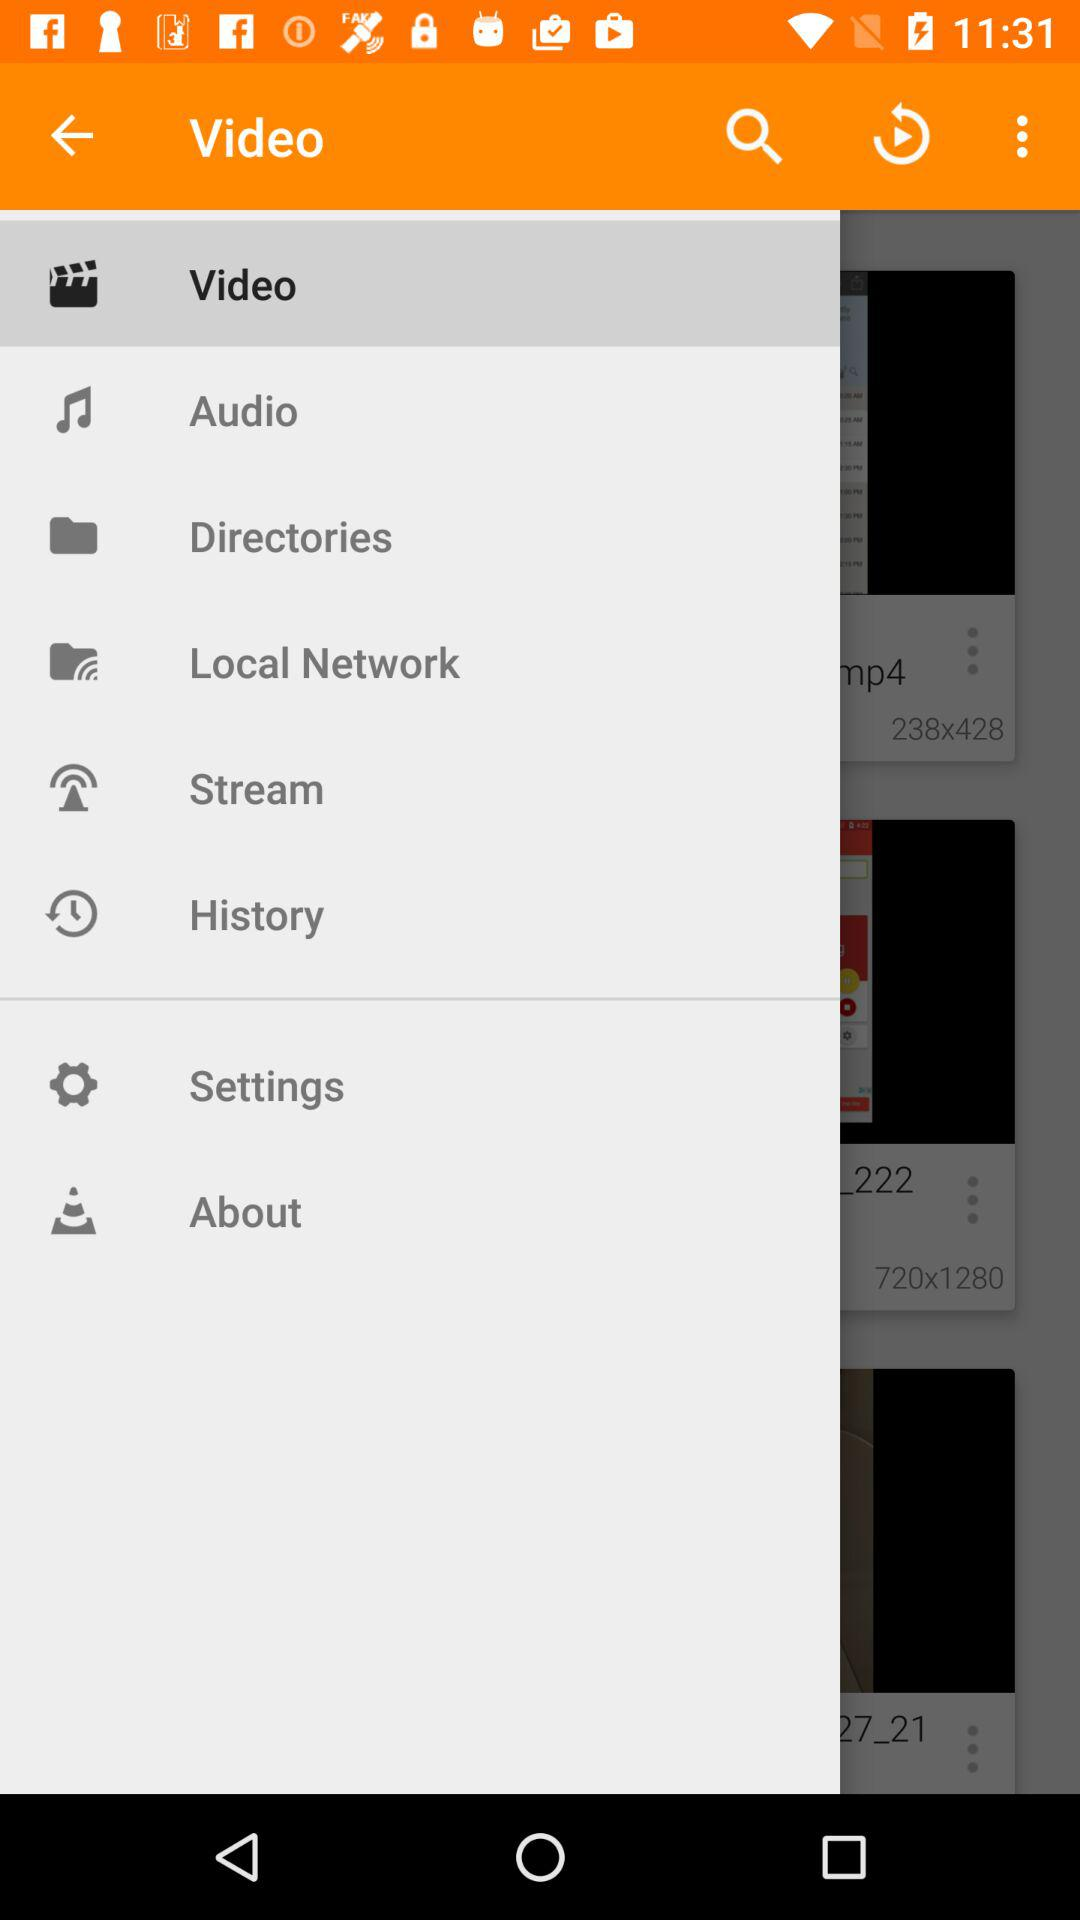Which item is selected? The selected item is "Video". 